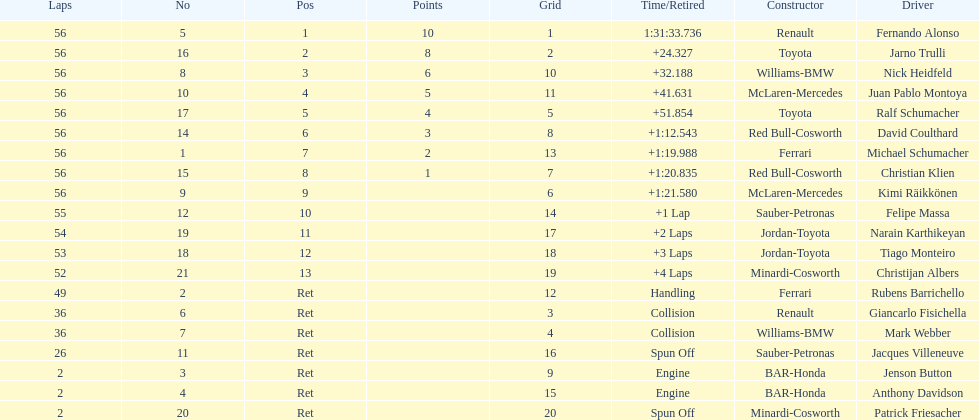How many bmws finished before webber? 1. 